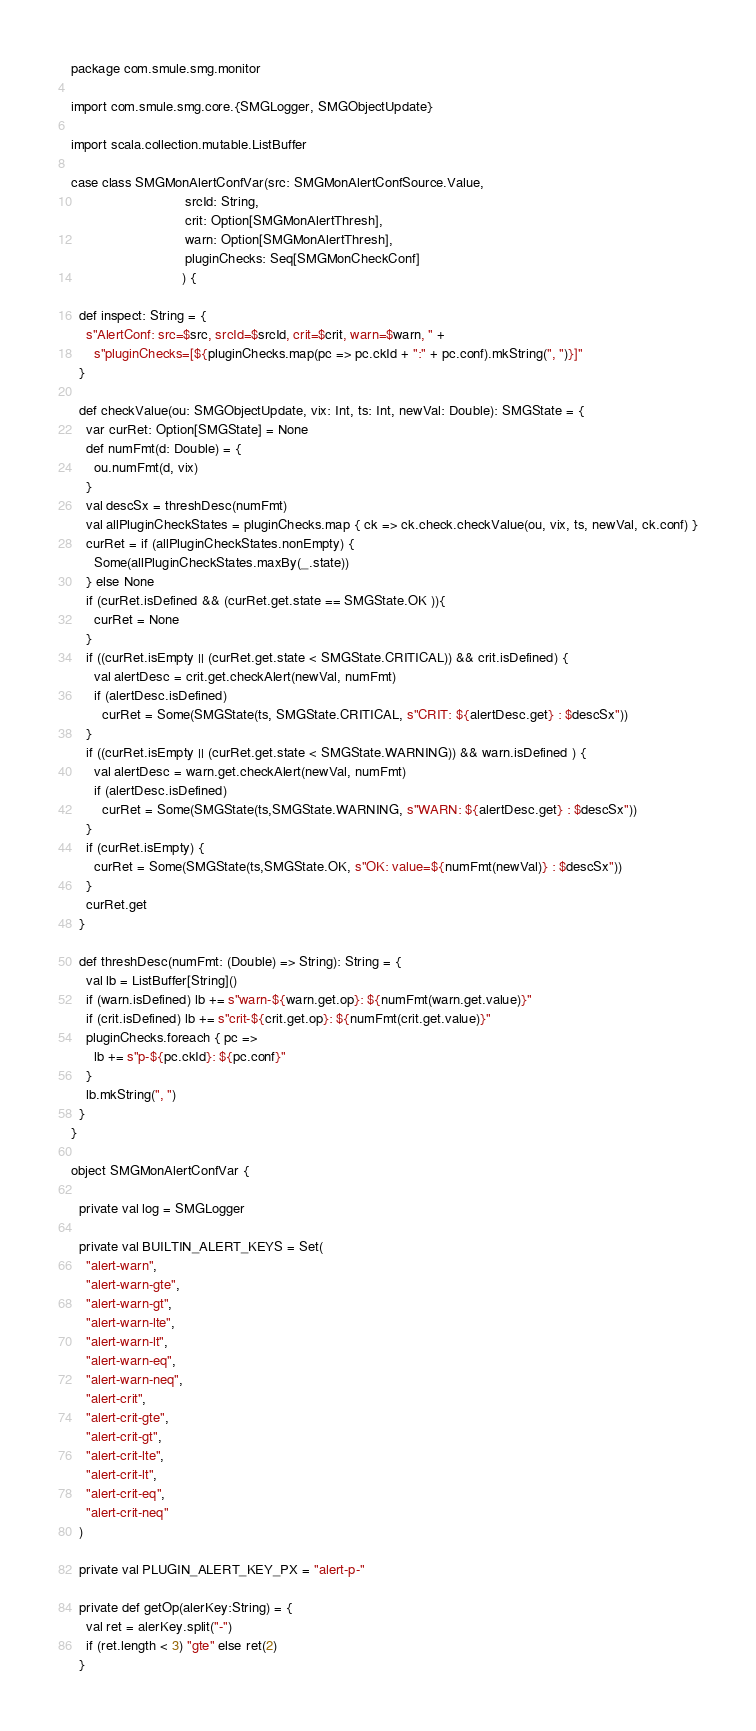Convert code to text. <code><loc_0><loc_0><loc_500><loc_500><_Scala_>package com.smule.smg.monitor

import com.smule.smg.core.{SMGLogger, SMGObjectUpdate}

import scala.collection.mutable.ListBuffer

case class SMGMonAlertConfVar(src: SMGMonAlertConfSource.Value,
                              srcId: String,
                              crit: Option[SMGMonAlertThresh],
                              warn: Option[SMGMonAlertThresh],
                              pluginChecks: Seq[SMGMonCheckConf]
                             ) {

  def inspect: String = {
    s"AlertConf: src=$src, srcId=$srcId, crit=$crit, warn=$warn, " +
      s"pluginChecks=[${pluginChecks.map(pc => pc.ckId + ":" + pc.conf).mkString(", ")}]"
  }

  def checkValue(ou: SMGObjectUpdate, vix: Int, ts: Int, newVal: Double): SMGState = {
    var curRet: Option[SMGState] = None
    def numFmt(d: Double) = {
      ou.numFmt(d, vix)
    }
    val descSx = threshDesc(numFmt)
    val allPluginCheckStates = pluginChecks.map { ck => ck.check.checkValue(ou, vix, ts, newVal, ck.conf) }
    curRet = if (allPluginCheckStates.nonEmpty) {
      Some(allPluginCheckStates.maxBy(_.state))
    } else None
    if (curRet.isDefined && (curRet.get.state == SMGState.OK )){
      curRet = None
    }
    if ((curRet.isEmpty || (curRet.get.state < SMGState.CRITICAL)) && crit.isDefined) {
      val alertDesc = crit.get.checkAlert(newVal, numFmt)
      if (alertDesc.isDefined)
        curRet = Some(SMGState(ts, SMGState.CRITICAL, s"CRIT: ${alertDesc.get} : $descSx"))
    }
    if ((curRet.isEmpty || (curRet.get.state < SMGState.WARNING)) && warn.isDefined ) {
      val alertDesc = warn.get.checkAlert(newVal, numFmt)
      if (alertDesc.isDefined)
        curRet = Some(SMGState(ts,SMGState.WARNING, s"WARN: ${alertDesc.get} : $descSx"))
    }
    if (curRet.isEmpty) {
      curRet = Some(SMGState(ts,SMGState.OK, s"OK: value=${numFmt(newVal)} : $descSx"))
    }
    curRet.get
  }

  def threshDesc(numFmt: (Double) => String): String = {
    val lb = ListBuffer[String]()
    if (warn.isDefined) lb += s"warn-${warn.get.op}: ${numFmt(warn.get.value)}"
    if (crit.isDefined) lb += s"crit-${crit.get.op}: ${numFmt(crit.get.value)}"
    pluginChecks.foreach { pc =>
      lb += s"p-${pc.ckId}: ${pc.conf}"
    }
    lb.mkString(", ")
  }
}

object SMGMonAlertConfVar {

  private val log = SMGLogger

  private val BUILTIN_ALERT_KEYS = Set(
    "alert-warn",
    "alert-warn-gte",
    "alert-warn-gt",
    "alert-warn-lte",
    "alert-warn-lt",
    "alert-warn-eq",
    "alert-warn-neq",
    "alert-crit",
    "alert-crit-gte",
    "alert-crit-gt",
    "alert-crit-lte",
    "alert-crit-lt",
    "alert-crit-eq",
    "alert-crit-neq"
  )

  private val PLUGIN_ALERT_KEY_PX = "alert-p-"

  private def getOp(alerKey:String) = {
    val ret = alerKey.split("-")
    if (ret.length < 3) "gte" else ret(2)
  }
</code> 